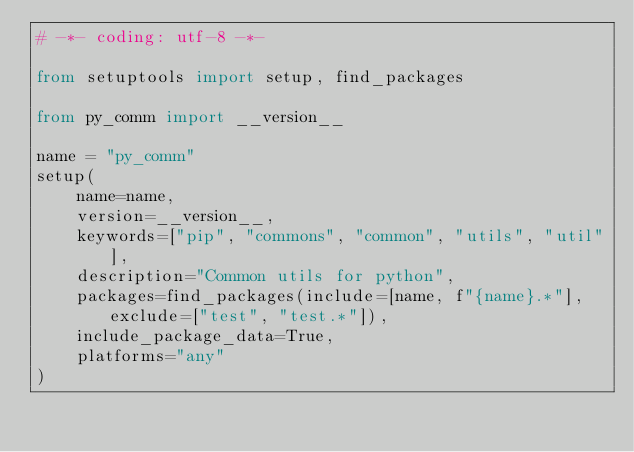<code> <loc_0><loc_0><loc_500><loc_500><_Python_># -*- coding: utf-8 -*-

from setuptools import setup, find_packages

from py_comm import __version__

name = "py_comm"
setup(
    name=name,
    version=__version__,
    keywords=["pip", "commons", "common", "utils", "util"],
    description="Common utils for python",
    packages=find_packages(include=[name, f"{name}.*"], exclude=["test", "test.*"]),
    include_package_data=True,
    platforms="any"
)
</code> 